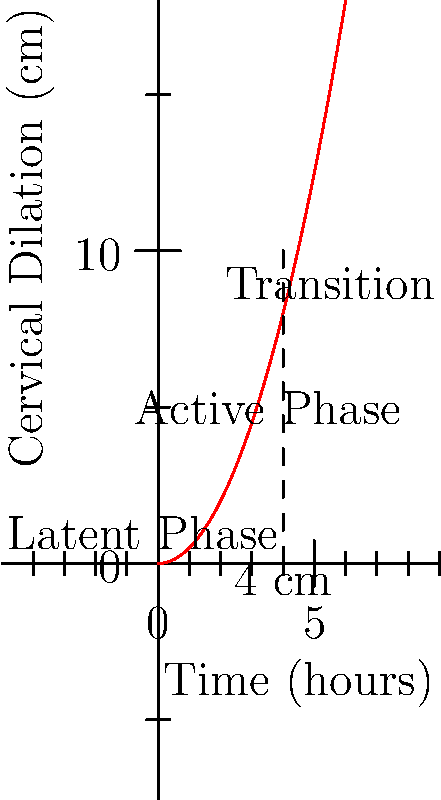Based on the partograph shown, at approximately what cervical dilation (in cm) does the active phase of labor typically begin? To answer this question, we need to analyze the partograph and understand the phases of labor:

1. The graph shows cervical dilation over time during labor.
2. The curve is divided into three distinct phases: latent, active, and transition.
3. The active phase is marked on the graph, starting at a specific point.
4. We can see a vertical dashed line at the 4 cm mark on the y-axis.
5. This line coincides with the beginning of the section labeled "Active Phase".
6. In obstetrics, it's widely accepted that the active phase of labor typically begins when the cervix is dilated to about 4 cm.
7. This aligns with the partograph representation, where the curve becomes steeper (indicating faster dilation) after the 4 cm mark.

Therefore, based on this partograph, the active phase of labor begins at approximately 4 cm of cervical dilation.
Answer: 4 cm 